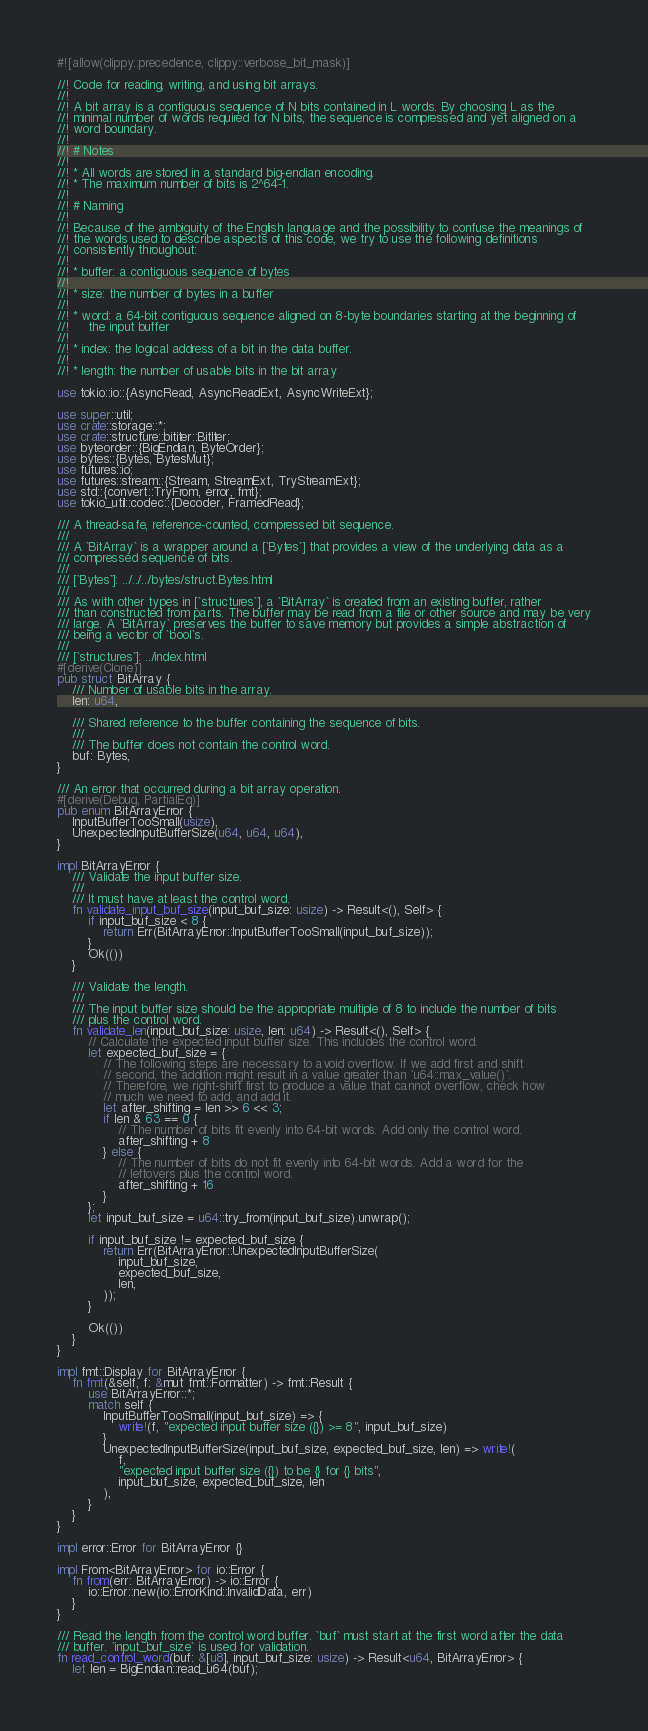<code> <loc_0><loc_0><loc_500><loc_500><_Rust_>#![allow(clippy::precedence, clippy::verbose_bit_mask)]

//! Code for reading, writing, and using bit arrays.
//!
//! A bit array is a contiguous sequence of N bits contained in L words. By choosing L as the
//! minimal number of words required for N bits, the sequence is compressed and yet aligned on a
//! word boundary.
//!
//! # Notes
//!
//! * All words are stored in a standard big-endian encoding.
//! * The maximum number of bits is 2^64-1.
//!
//! # Naming
//!
//! Because of the ambiguity of the English language and the possibility to confuse the meanings of
//! the words used to describe aspects of this code, we try to use the following definitions
//! consistently throughout:
//!
//! * buffer: a contiguous sequence of bytes
//!
//! * size: the number of bytes in a buffer
//!
//! * word: a 64-bit contiguous sequence aligned on 8-byte boundaries starting at the beginning of
//!     the input buffer
//!
//! * index: the logical address of a bit in the data buffer.
//!
//! * length: the number of usable bits in the bit array

use tokio::io::{AsyncRead, AsyncReadExt, AsyncWriteExt};

use super::util;
use crate::storage::*;
use crate::structure::bititer::BitIter;
use byteorder::{BigEndian, ByteOrder};
use bytes::{Bytes, BytesMut};
use futures::io;
use futures::stream::{Stream, StreamExt, TryStreamExt};
use std::{convert::TryFrom, error, fmt};
use tokio_util::codec::{Decoder, FramedRead};

/// A thread-safe, reference-counted, compressed bit sequence.
///
/// A `BitArray` is a wrapper around a [`Bytes`] that provides a view of the underlying data as a
/// compressed sequence of bits.
///
/// [`Bytes`]: ../../../bytes/struct.Bytes.html
///
/// As with other types in [`structures`], a `BitArray` is created from an existing buffer, rather
/// than constructed from parts. The buffer may be read from a file or other source and may be very
/// large. A `BitArray` preserves the buffer to save memory but provides a simple abstraction of
/// being a vector of `bool`s.
///
/// [`structures`]: ../index.html
#[derive(Clone)]
pub struct BitArray {
    /// Number of usable bits in the array.
    len: u64,

    /// Shared reference to the buffer containing the sequence of bits.
    ///
    /// The buffer does not contain the control word.
    buf: Bytes,
}

/// An error that occurred during a bit array operation.
#[derive(Debug, PartialEq)]
pub enum BitArrayError {
    InputBufferTooSmall(usize),
    UnexpectedInputBufferSize(u64, u64, u64),
}

impl BitArrayError {
    /// Validate the input buffer size.
    ///
    /// It must have at least the control word.
    fn validate_input_buf_size(input_buf_size: usize) -> Result<(), Self> {
        if input_buf_size < 8 {
            return Err(BitArrayError::InputBufferTooSmall(input_buf_size));
        }
        Ok(())
    }

    /// Validate the length.
    ///
    /// The input buffer size should be the appropriate multiple of 8 to include the number of bits
    /// plus the control word.
    fn validate_len(input_buf_size: usize, len: u64) -> Result<(), Self> {
        // Calculate the expected input buffer size. This includes the control word.
        let expected_buf_size = {
            // The following steps are necessary to avoid overflow. If we add first and shift
            // second, the addition might result in a value greater than `u64::max_value()`.
            // Therefore, we right-shift first to produce a value that cannot overflow, check how
            // much we need to add, and add it.
            let after_shifting = len >> 6 << 3;
            if len & 63 == 0 {
                // The number of bits fit evenly into 64-bit words. Add only the control word.
                after_shifting + 8
            } else {
                // The number of bits do not fit evenly into 64-bit words. Add a word for the
                // leftovers plus the control word.
                after_shifting + 16
            }
        };
        let input_buf_size = u64::try_from(input_buf_size).unwrap();

        if input_buf_size != expected_buf_size {
            return Err(BitArrayError::UnexpectedInputBufferSize(
                input_buf_size,
                expected_buf_size,
                len,
            ));
        }

        Ok(())
    }
}

impl fmt::Display for BitArrayError {
    fn fmt(&self, f: &mut fmt::Formatter) -> fmt::Result {
        use BitArrayError::*;
        match self {
            InputBufferTooSmall(input_buf_size) => {
                write!(f, "expected input buffer size ({}) >= 8", input_buf_size)
            }
            UnexpectedInputBufferSize(input_buf_size, expected_buf_size, len) => write!(
                f,
                "expected input buffer size ({}) to be {} for {} bits",
                input_buf_size, expected_buf_size, len
            ),
        }
    }
}

impl error::Error for BitArrayError {}

impl From<BitArrayError> for io::Error {
    fn from(err: BitArrayError) -> io::Error {
        io::Error::new(io::ErrorKind::InvalidData, err)
    }
}

/// Read the length from the control word buffer. `buf` must start at the first word after the data
/// buffer. `input_buf_size` is used for validation.
fn read_control_word(buf: &[u8], input_buf_size: usize) -> Result<u64, BitArrayError> {
    let len = BigEndian::read_u64(buf);</code> 